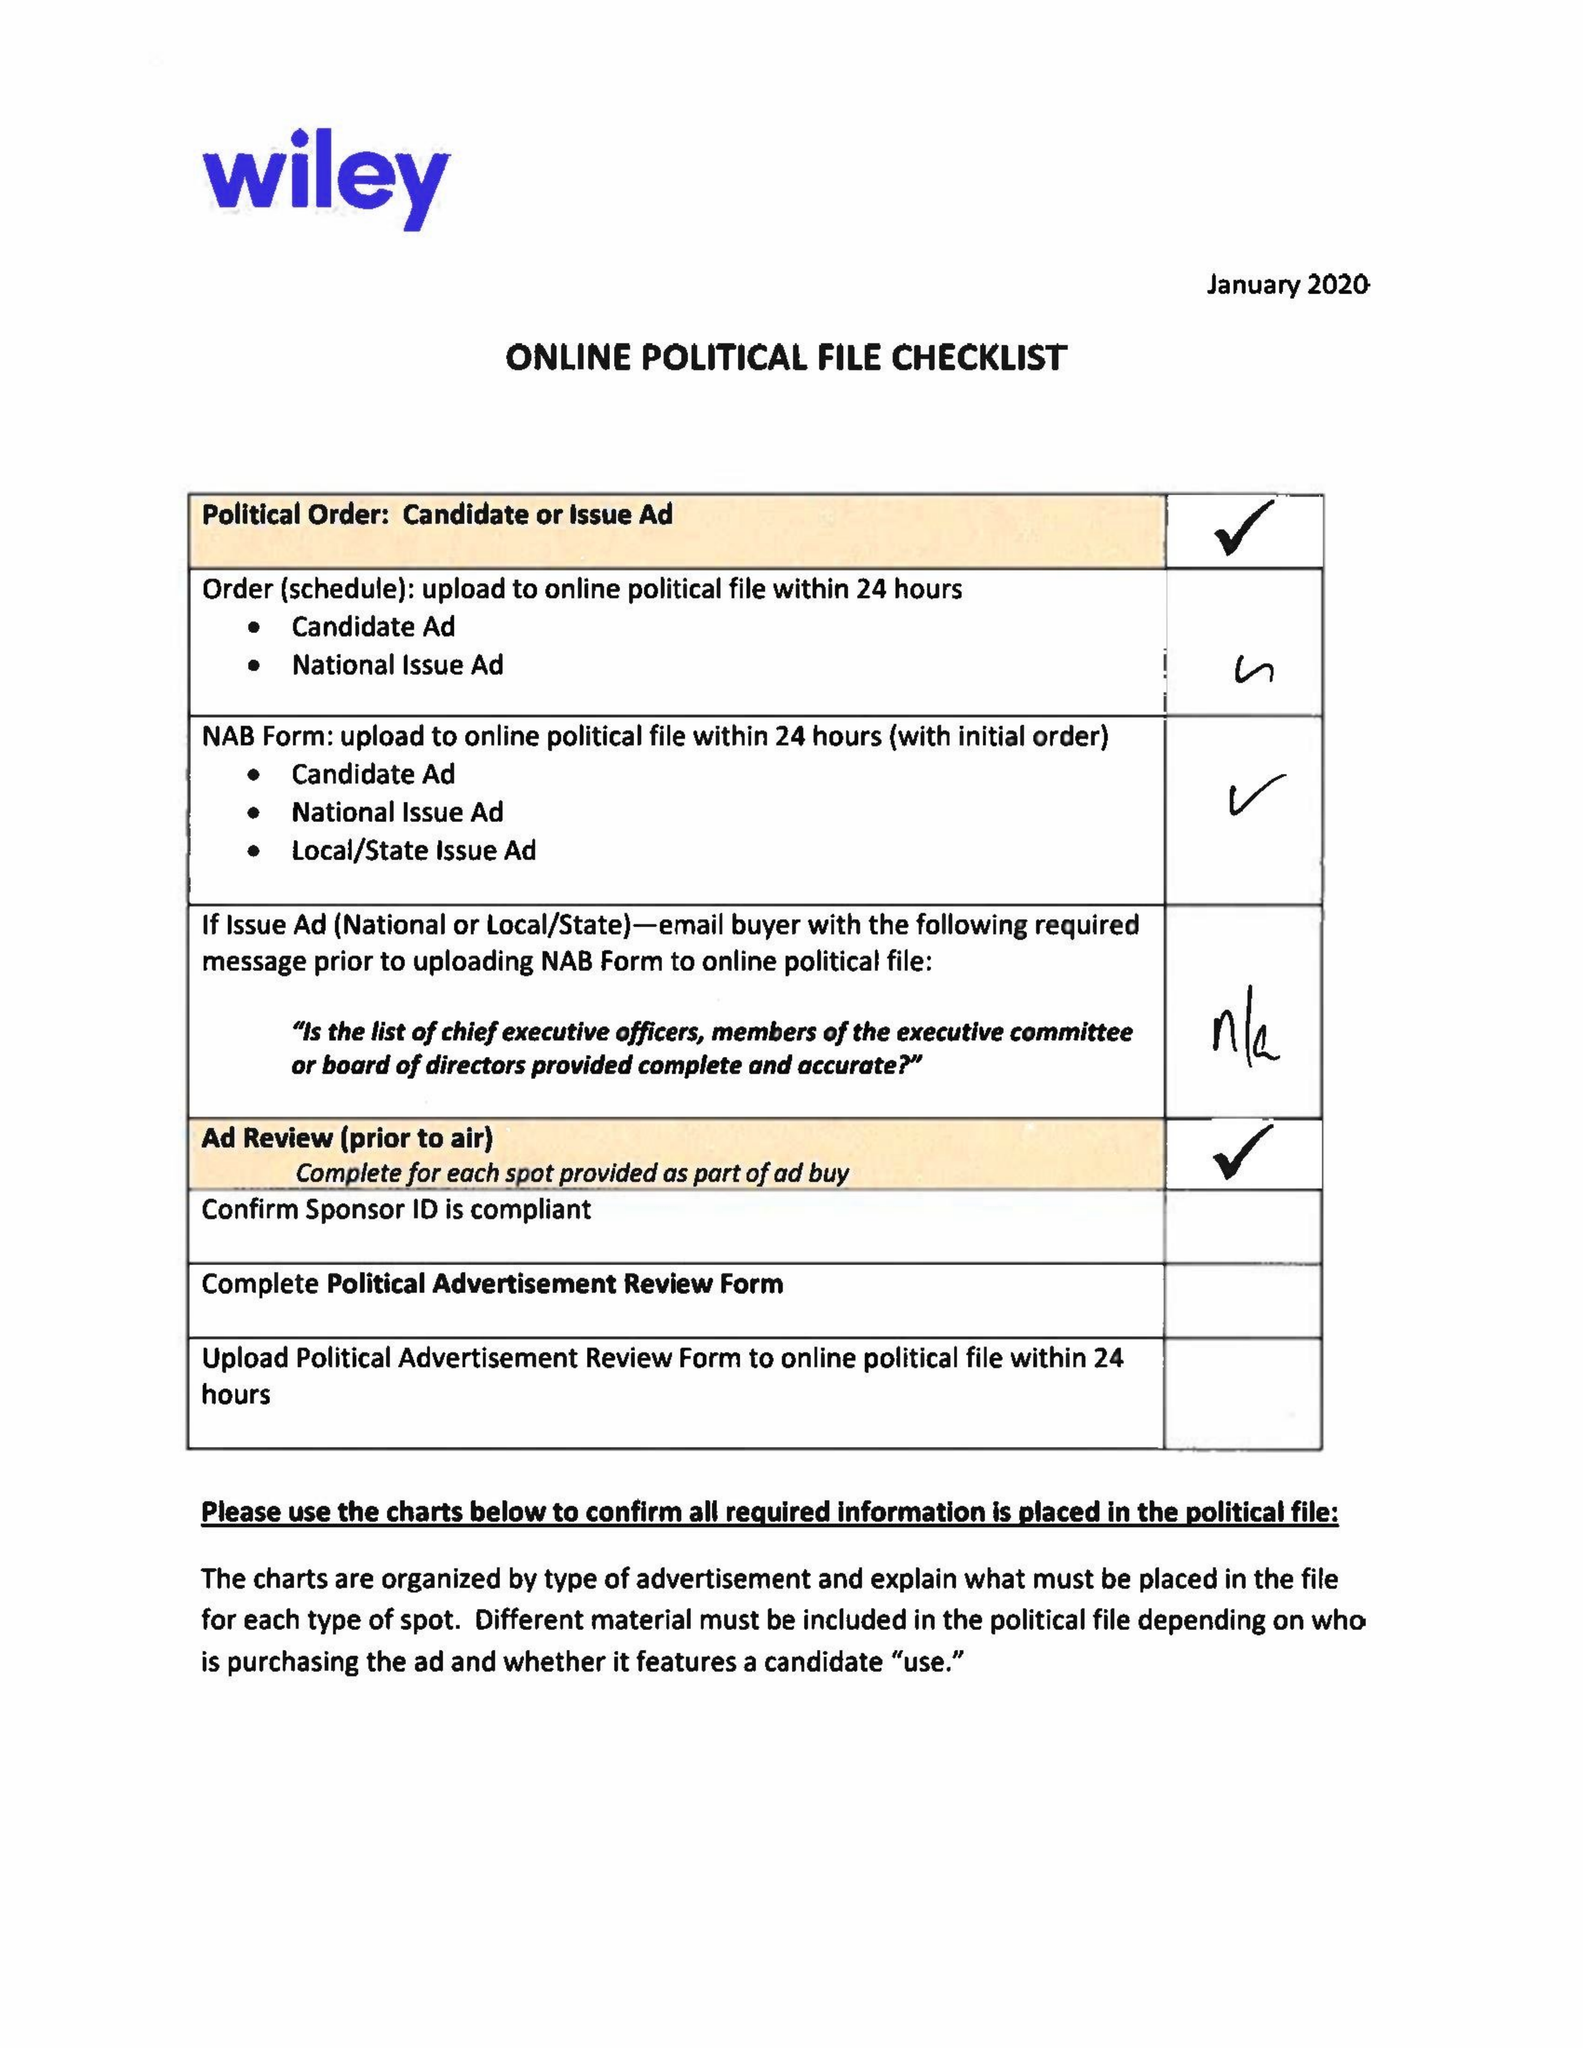What is the value for the flight_from?
Answer the question using a single word or phrase. 02/29/20 